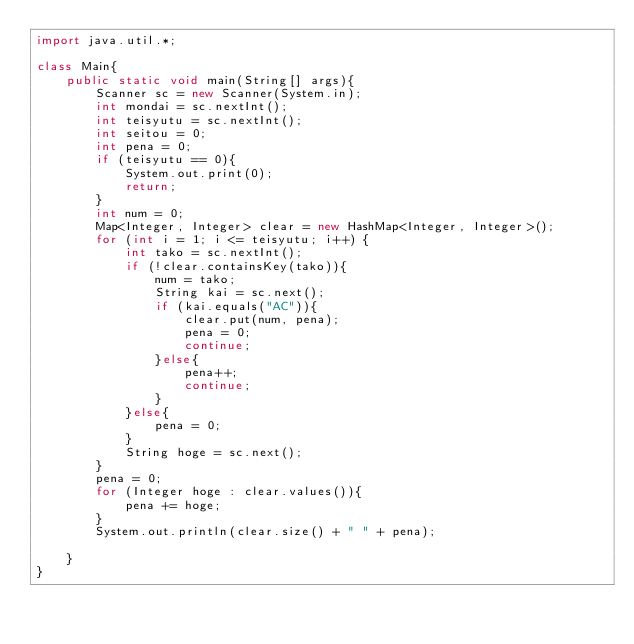<code> <loc_0><loc_0><loc_500><loc_500><_Java_>import java.util.*;

class Main{
	public static void main(String[] args){
		Scanner sc = new Scanner(System.in);
		int mondai = sc.nextInt();
		int teisyutu = sc.nextInt();
		int seitou = 0;
		int pena = 0;
		if (teisyutu == 0){
			System.out.print(0);
			return;
		}
        int num = 0;
        Map<Integer, Integer> clear = new HashMap<Integer, Integer>();
		for (int i = 1; i <= teisyutu; i++) {
          	int tako = sc.nextInt();
          	if (!clear.containsKey(tako)){
              	num = tako;
				String kai = sc.next();
              	if (kai.equals("AC")){
                	clear.put(num, pena);
                  	pena = 0;
                  	continue;
                }else{
                    pena++;
                  	continue;
                }
            }else{
            	pena = 0;
            }
          	String hoge = sc.next();
		}
      	pena = 0;
		for (Integer hoge : clear.values()){
        	pena += hoge;
        }
      	System.out.println(clear.size() + " " + pena);
      
	}
}
</code> 